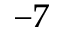<formula> <loc_0><loc_0><loc_500><loc_500>^ { - 7 }</formula> 